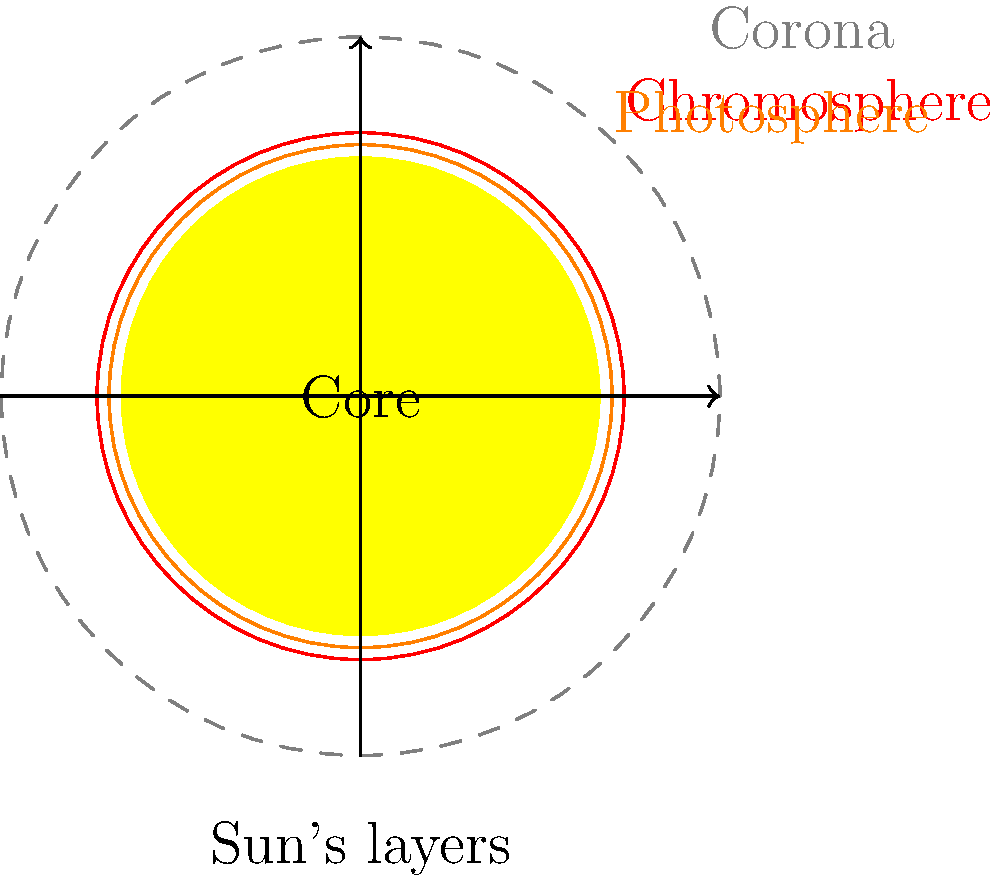In the context of cinematic storytelling, imagine you're directing a sci-fi film about a journey to the Sun. Your protagonist must navigate through the Sun's atmospheric layers. Using the cross-sectional diagram, identify the layer that would serve as the dramatic "point of no return" for your character, known for its intense heat and vibrant red color, often featured in solar eclipse footage. To answer this question, let's break down the layers of the Sun's atmosphere as shown in the diagram, relating each to potential dramatic elements in a sci-fi film:

1. Corona: The outermost layer, represented by the dashed gray line. While visually stunning, it's not the most dramatic "point of no return."

2. Chromosphere: The next layer inward, shown as a red circle. This layer is known for its:
   a) Intense heat (around 20,000°C)
   b) Vibrant red color
   c) Visibility during solar eclipses

3. Photosphere: The innermost layer in the diagram, represented by the orange circle. While important, it's not as visually distinctive as the chromosphere.

4. Core: The center of the Sun, not part of the atmosphere.

For a film director, the chromosphere offers the most cinematic potential:
- Its red color provides a visually striking backdrop
- The extreme heat creates tension and danger for the protagonist
- Its visibility during solar eclipses makes it recognizable to audiences

This layer would serve as an excellent "point of no return" in your sci-fi narrative, marking the moment where the journey becomes perilous and visually spectacular.
Answer: Chromosphere 